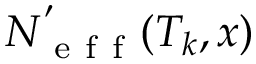<formula> <loc_0><loc_0><loc_500><loc_500>N _ { e f f } ^ { ^ { \prime } } ( T _ { k } , x )</formula> 